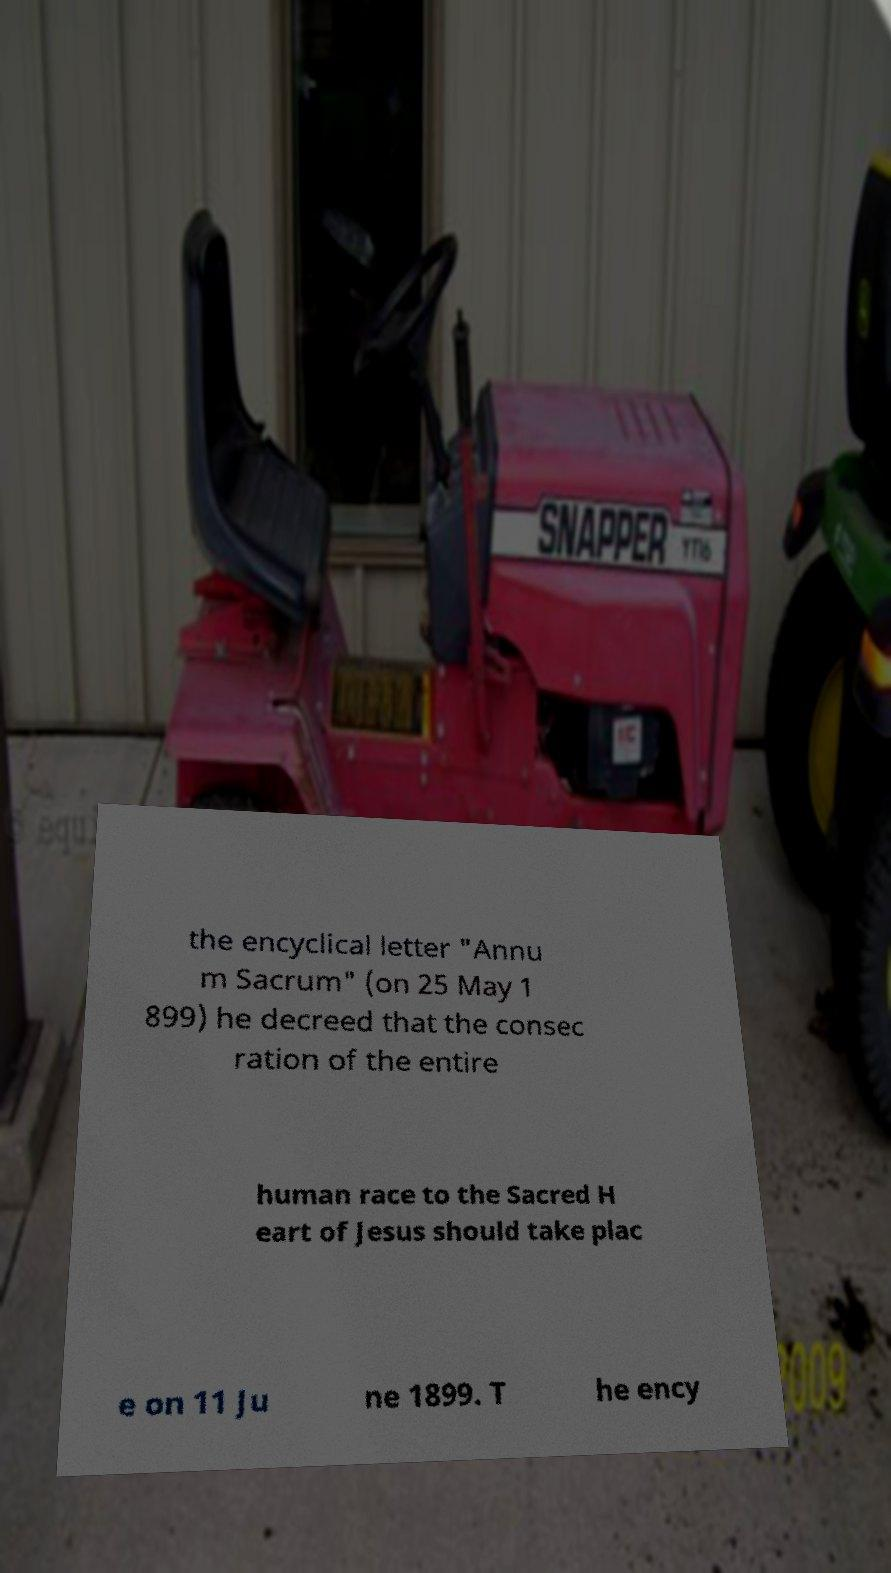There's text embedded in this image that I need extracted. Can you transcribe it verbatim? the encyclical letter "Annu m Sacrum" (on 25 May 1 899) he decreed that the consec ration of the entire human race to the Sacred H eart of Jesus should take plac e on 11 Ju ne 1899. T he ency 